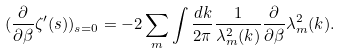Convert formula to latex. <formula><loc_0><loc_0><loc_500><loc_500>( \frac { \partial } { \partial \beta } \zeta ^ { \prime } ( s ) ) _ { s = 0 } = - 2 \sum _ { m } \int \frac { d k } { 2 \pi } \frac { 1 } { \lambda _ { m } ^ { 2 } ( k ) } \frac { \partial } { \partial \beta } \lambda _ { m } ^ { 2 } ( k ) .</formula> 